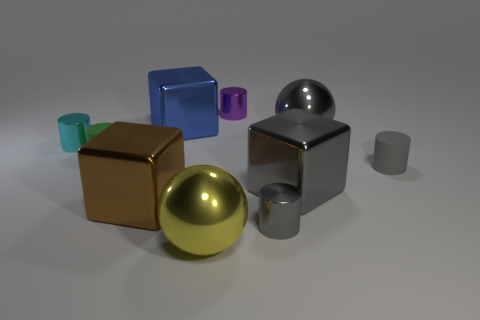Subtract all gray metal cylinders. How many cylinders are left? 4 Subtract 1 blocks. How many blocks are left? 2 Subtract all spheres. How many objects are left? 8 Subtract all red cylinders. How many green blocks are left? 0 Subtract all small green things. Subtract all big brown blocks. How many objects are left? 8 Add 2 small gray cylinders. How many small gray cylinders are left? 4 Add 2 gray metallic cylinders. How many gray metallic cylinders exist? 3 Subtract all brown blocks. How many blocks are left? 2 Subtract 0 yellow blocks. How many objects are left? 10 Subtract all red cylinders. Subtract all purple spheres. How many cylinders are left? 5 